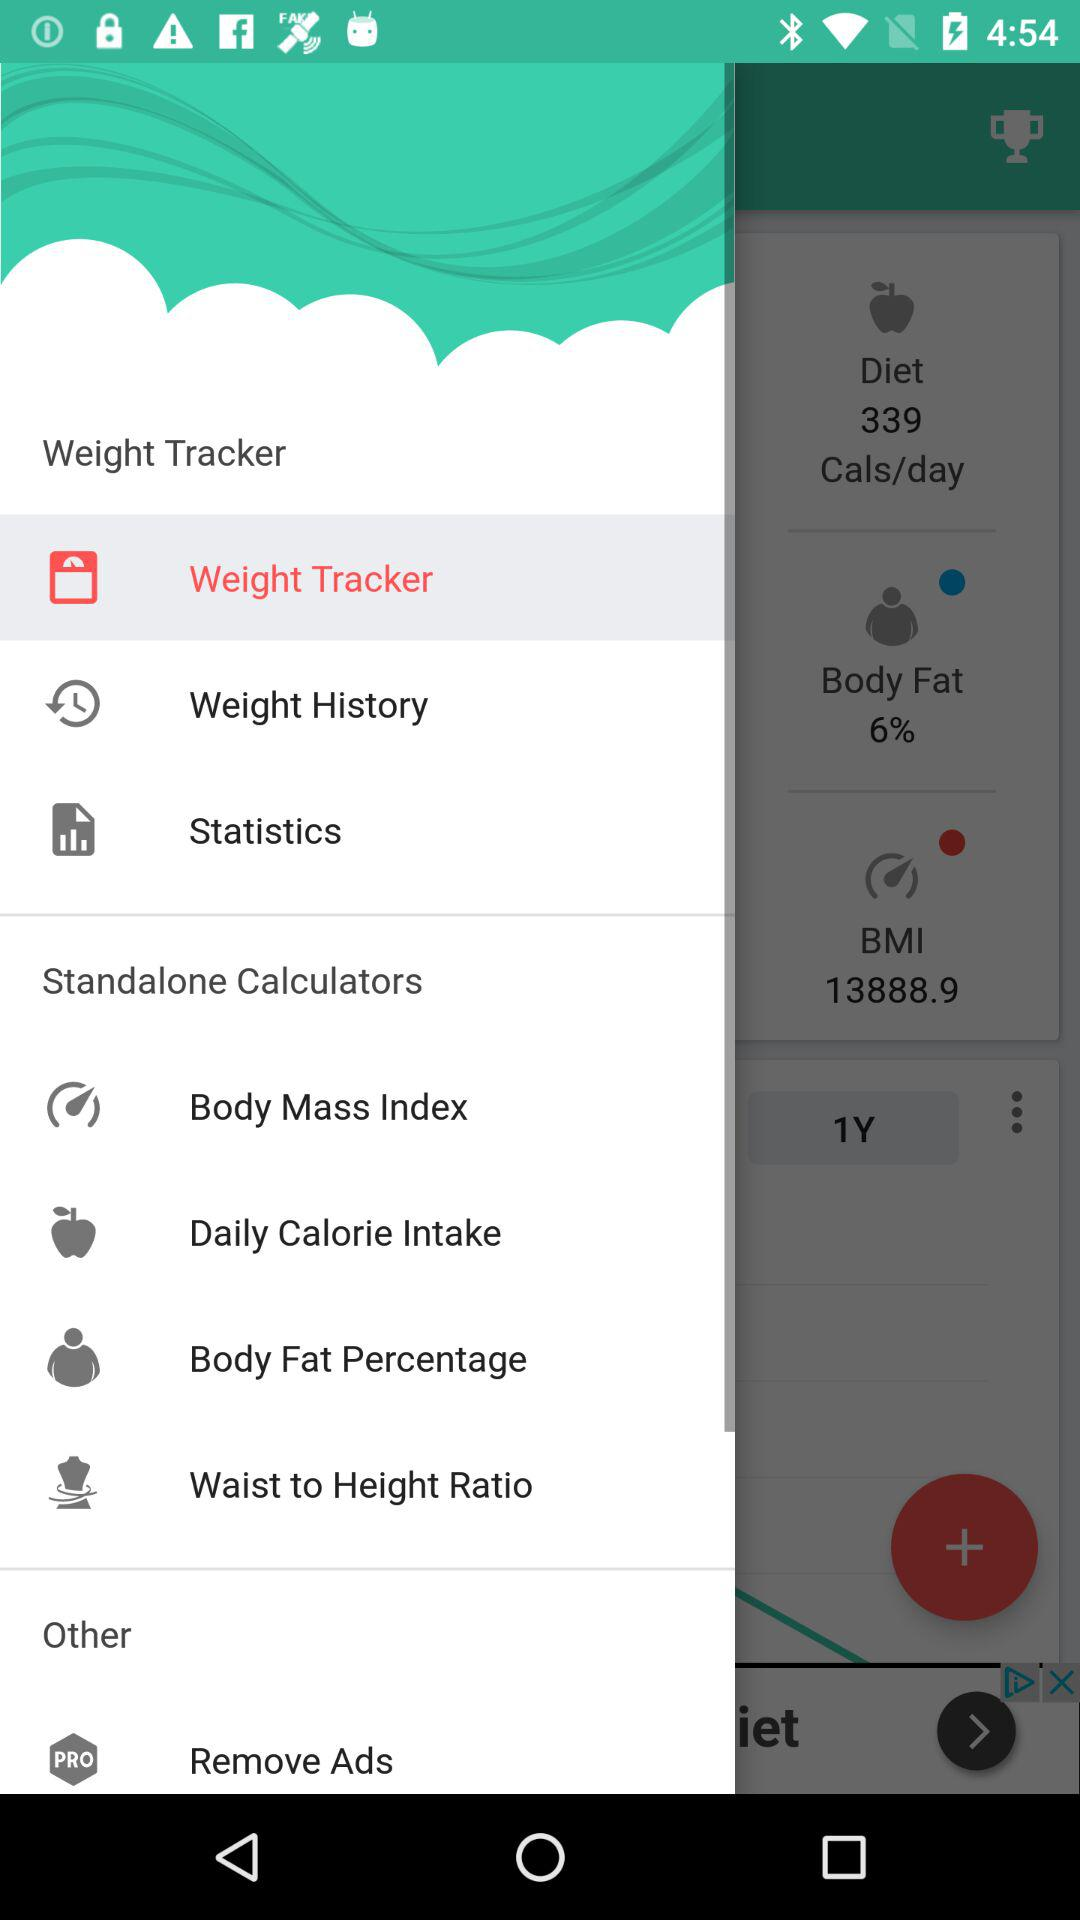Which option is selected? The selected option is "Weight Tracker". 